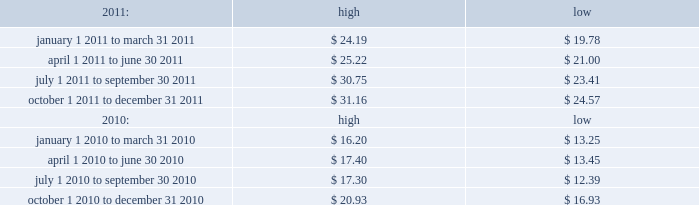Table of contents index to financial statements item 3 .
Legal proceedings .
Item 4 .
Mine safety disclosures .
Not applicable .
Part ii price range our common stock trades on the nasdaq global select market under the symbol 201cmktx 201d .
The range of closing price information for our common stock , as reported by nasdaq , was as follows : on february 16 , 2012 , the last reported closing price of our common stock on the nasdaq global select market was $ 32.65 .
Holders there were 41 holders of record of our common stock as of february 16 , 2012 .
Dividend policy we initiated a regular quarterly dividend in the fourth quarter of 2009 .
During 2010 and 2011 , we paid quarterly cash dividends of $ 0.07 per share and $ 0.09 per share , respectively .
In january 2012 , our board of directors approved a quarterly cash dividend of $ 0.11 per share payable on march 1 , 2012 to stockholders of record as of the close of business on february 16 , 2012 .
Any future declaration and payment of dividends will be at the sole discretion of the company 2019s board of directors .
The board of directors may take into account such matters as general business conditions , the company 2019s financial results , capital requirements , contractual , legal , and regulatory restrictions on the payment of dividends to the company 2019s stockholders or by the company 2019s subsidiaries to the parent and any such other factors as the board of directors may deem relevant .
Recent sales of unregistered securities item 5 .
Market for registrant 2019s common equity , related stockholder matters and issuer purchases of equity securities. .

What was the total cash dividend paid to holders of common stock as of february 12 , 2012? 
Computations: (41 * 0.11)
Answer: 4.51. Table of contents index to financial statements item 3 .
Legal proceedings .
Item 4 .
Mine safety disclosures .
Not applicable .
Part ii price range our common stock trades on the nasdaq global select market under the symbol 201cmktx 201d .
The range of closing price information for our common stock , as reported by nasdaq , was as follows : on february 16 , 2012 , the last reported closing price of our common stock on the nasdaq global select market was $ 32.65 .
Holders there were 41 holders of record of our common stock as of february 16 , 2012 .
Dividend policy we initiated a regular quarterly dividend in the fourth quarter of 2009 .
During 2010 and 2011 , we paid quarterly cash dividends of $ 0.07 per share and $ 0.09 per share , respectively .
In january 2012 , our board of directors approved a quarterly cash dividend of $ 0.11 per share payable on march 1 , 2012 to stockholders of record as of the close of business on february 16 , 2012 .
Any future declaration and payment of dividends will be at the sole discretion of the company 2019s board of directors .
The board of directors may take into account such matters as general business conditions , the company 2019s financial results , capital requirements , contractual , legal , and regulatory restrictions on the payment of dividends to the company 2019s stockholders or by the company 2019s subsidiaries to the parent and any such other factors as the board of directors may deem relevant .
Recent sales of unregistered securities item 5 .
Market for registrant 2019s common equity , related stockholder matters and issuer purchases of equity securities. .

Based on the total holders of common stock as of february 16 , 2012 , what was the market share of mktx common stock? 
Computations: (32.65 * 41)
Answer: 1338.65. Table of contents index to financial statements item 3 .
Legal proceedings .
Item 4 .
Mine safety disclosures .
Not applicable .
Part ii price range our common stock trades on the nasdaq global select market under the symbol 201cmktx 201d .
The range of closing price information for our common stock , as reported by nasdaq , was as follows : on february 16 , 2012 , the last reported closing price of our common stock on the nasdaq global select market was $ 32.65 .
Holders there were 41 holders of record of our common stock as of february 16 , 2012 .
Dividend policy we initiated a regular quarterly dividend in the fourth quarter of 2009 .
During 2010 and 2011 , we paid quarterly cash dividends of $ 0.07 per share and $ 0.09 per share , respectively .
In january 2012 , our board of directors approved a quarterly cash dividend of $ 0.11 per share payable on march 1 , 2012 to stockholders of record as of the close of business on february 16 , 2012 .
Any future declaration and payment of dividends will be at the sole discretion of the company 2019s board of directors .
The board of directors may take into account such matters as general business conditions , the company 2019s financial results , capital requirements , contractual , legal , and regulatory restrictions on the payment of dividends to the company 2019s stockholders or by the company 2019s subsidiaries to the parent and any such other factors as the board of directors may deem relevant .
Recent sales of unregistered securities item 5 .
Market for registrant 2019s common equity , related stockholder matters and issuer purchases of equity securities. .

For the period from april 1 2011 to june 30 2011 , what was the difference between high and low stock price? 
Computations: (25.22 - 21.00)
Answer: 4.22. 